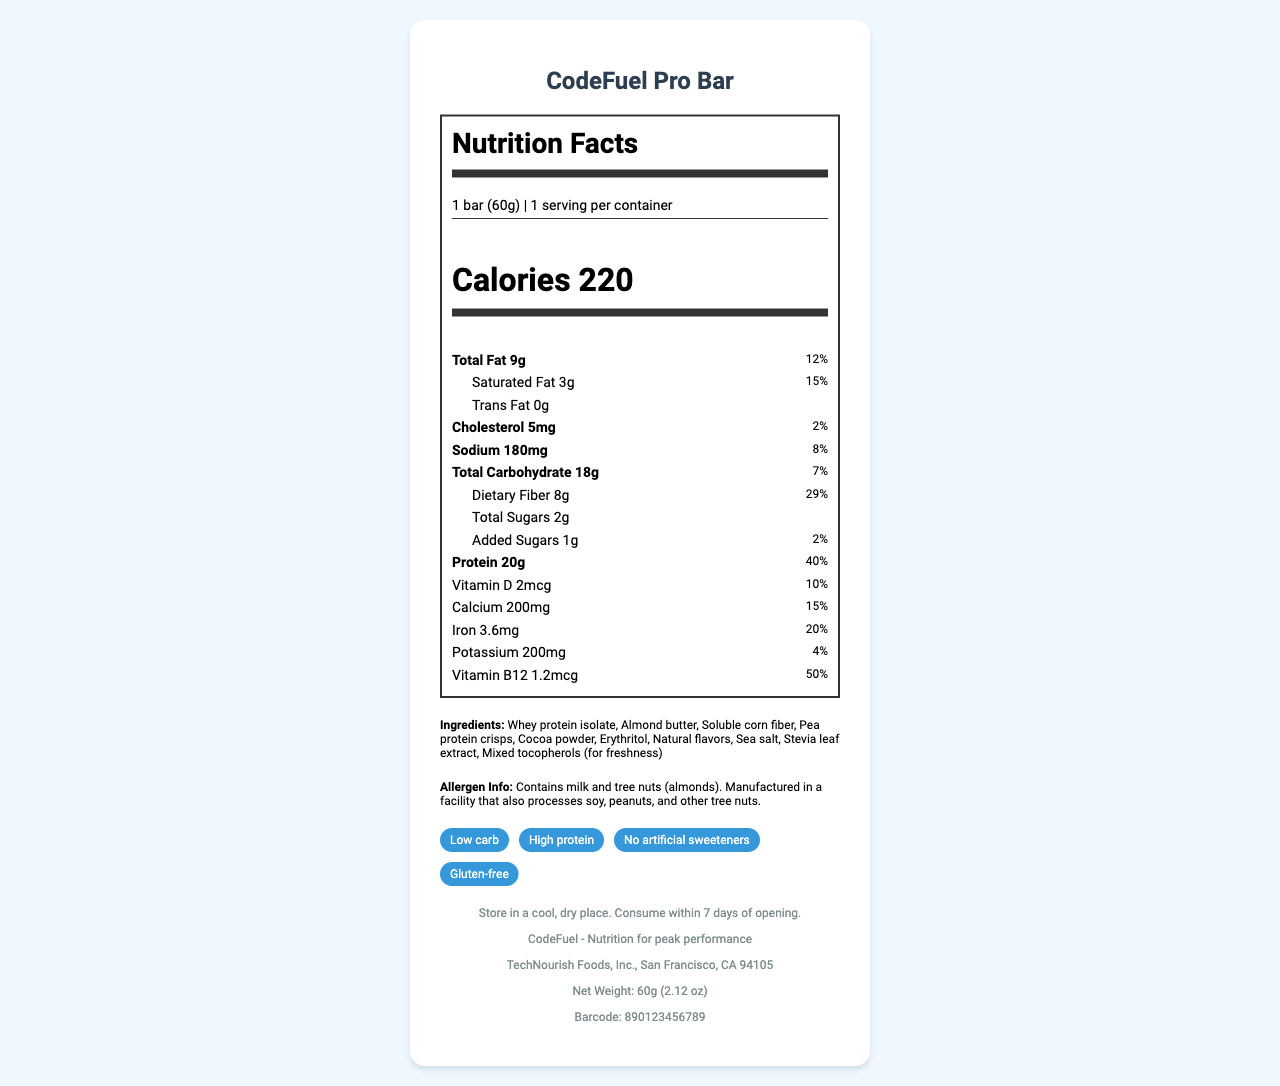what is the serving size of the CodeFuel Pro Bar? The serving size is indicated at the top of the Nutrition Facts section as "1 bar (60g)".
Answer: 1 bar (60g) how many calories are in one serving of the CodeFuel Pro Bar? The calorie content per serving is listed prominently in the Nutrition Facts section as 220 calories.
Answer: 220 what is the amount of protein in the bar, and what percentage of the daily value does it represent? The amount of protein is listed as 20g and its corresponding daily value percentage is 40%.
Answer: 20g, 40% which vitamins and minerals are included in the bar, and what are their respective daily values? The vitamins and minerals along with their daily values are listed in the Nutrition Facts section. Vitamin D, Calcium, Iron, Potassium, and Vitamin B12 are mentioned, along with their daily values.
Answer: Vitamin D: 2mcg (10%), Calcium: 200mg (15%), Iron: 3.6mg (20%), Potassium: 200mg (4%), Vitamin B12: 1.2mcg (50%) what allergen information is provided for the CodeFuel Pro Bar? The allergen information is specified in the ingredients section below the Nutrition Facts label.
Answer: Contains milk and tree nuts (almonds). Manufactured in a facility that also processes soy, peanuts, and other tree nuts. what are the storage instructions for the CodeFuel Pro Bar? The storage instructions are found towards the bottom of the document, indicating how the product should be stored and its shelf life after opening.
Answer: Store in a cool, dry place. Consume within 7 days of opening. which ingredient is NOT found in the CodeFuel Pro Bar? A. Almond butter B. Sucralose C. Whey protein isolate D. Stevia leaf extract According to the list of ingredients, Sucralose is not part of this bar. The listed ingredients include Whey protein isolate, Almond butter, Stevia leaf extract, among others.
Answer: B. Sucralose which claim is NOT made about the CodeFuel Pro Bar? I. Low carb II. Contains artificial sweeteners III. High protein IV. Gluten-free The claim "Contains artificial sweeteners" is not made. Instead, it says "No artificial sweeteners". The bar claims to be Low carb, High protein, and Gluten-free.
Answer: II. Contains artificial sweeteners does the document mention if the bar is gluten-free? The claim section explicitly states that the bar is Gluten-free.
Answer: Yes summarize the main idea of the document within three sentences. The summary covers the main aspects of the document, noting the nutritional details and target audience, as well as other relevant product information.
Answer: The document provides comprehensive nutritional information about the CodeFuel Pro Bar. It highlights the bar's key nutritional elements, ingredients, claims, and allergen information, designed to serve busy software engineers in need of a low-carb, high-protein meal replacement. Additional details about storage, branding, and manufacturer information are also included. how many bars are in one container? The document states that there is 1 serving per container, which means there's only 1 bar per container.
Answer: 1 how much vitamin A is in the CodeFuel Pro Bar? The document does not list vitamin A in the nutritional information, hence its amount cannot be determined from the available information.
Answer: Not enough information what percentage of the daily value of dietary fiber does the bar provide? The amount of dietary fiber is 8g, and this represents 29% of the daily value, as listed in the nutritional information.
Answer: 29% 